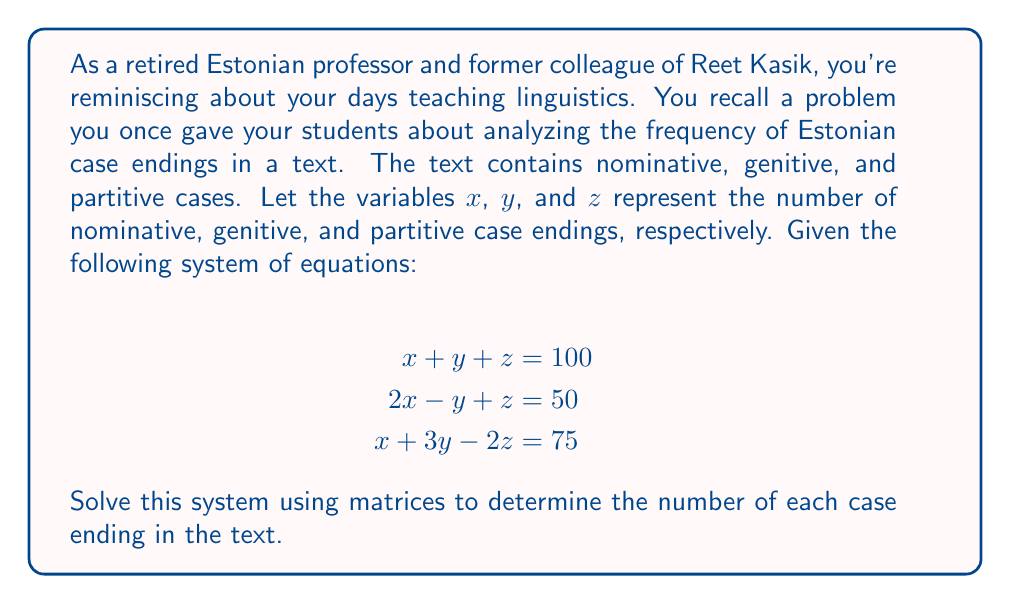Can you answer this question? To solve this system using matrices, we'll follow these steps:

1) First, let's write the system in augmented matrix form:

   $$\left[\begin{array}{ccc|c}
   1 & 1 & 1 & 100 \\
   2 & -1 & 1 & 50 \\
   1 & 3 & -2 & 75
   \end{array}\right]$$

2) Now, we'll use Gaussian elimination to transform this into row echelon form:

   a) Multiply the first row by -2 and add to the second row:
      $$\left[\begin{array}{ccc|c}
      1 & 1 & 1 & 100 \\
      0 & -3 & -1 & -150 \\
      1 & 3 & -2 & 75
      \end{array}\right]$$

   b) Subtract the first row from the third row:
      $$\left[\begin{array}{ccc|c}
      1 & 1 & 1 & 100 \\
      0 & -3 & -1 & -150 \\
      0 & 2 & -3 & -25
      \end{array}\right]$$

3) Now, let's continue to reduced row echelon form:

   c) Multiply the second row by -1/3:
      $$\left[\begin{array}{ccc|c}
      1 & 1 & 1 & 100 \\
      0 & 1 & 1/3 & 50 \\
      0 & 2 & -3 & -25
      \end{array}\right]$$

   d) Multiply the second row by -2 and add to the third row:
      $$\left[\begin{array}{ccc|c}
      1 & 1 & 1 & 100 \\
      0 & 1 & 1/3 & 50 \\
      0 & 0 & -11/3 & -125
      \end{array}\right]$$

   e) Multiply the third row by -3/11:
      $$\left[\begin{array}{ccc|c}
      1 & 1 & 1 & 100 \\
      0 & 1 & 1/3 & 50 \\
      0 & 0 & 1 & 125/11
      \end{array}\right]$$

4) Now we can solve by back-substitution:

   $z = 125/11$
   $y + 1/3(125/11) = 50$, so $y = 50 - 125/33 = 1525/33$
   $x + 1525/33 + 125/11 = 100$, so $x = 100 - 1525/33 - 125/11 = 275/33$

5) Therefore, the solution is:
   $x = 275/33 \approx 8.33$
   $y = 1525/33 \approx 46.21$
   $z = 125/11 \approx 11.36$

Since we're dealing with whole numbers of case endings, we should round these to the nearest integer.
Answer: Nominative case endings (x): 8
Genitive case endings (y): 46
Partitive case endings (z): 11 